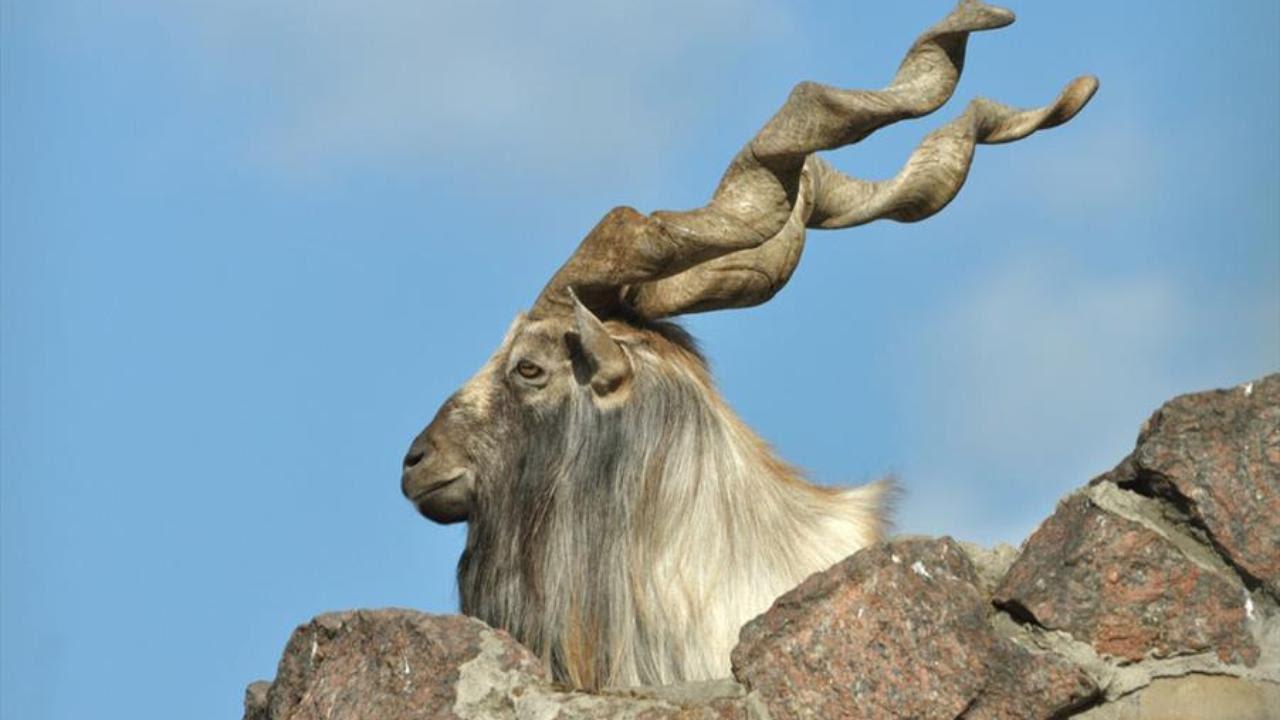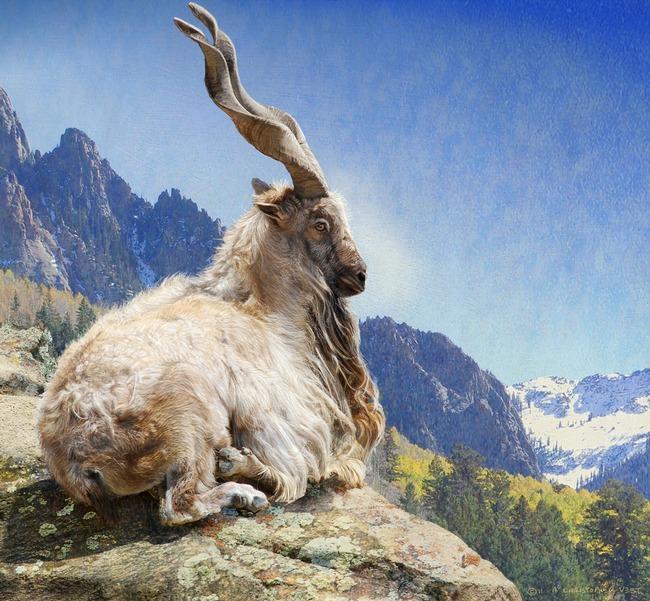The first image is the image on the left, the second image is the image on the right. For the images displayed, is the sentence "The left and right image contains the same number of goats facing the same direction." factually correct? Answer yes or no. No. The first image is the image on the left, the second image is the image on the right. Given the left and right images, does the statement "Each image contains one horned animal in front of a wall of rock, and the animals in the left and right images face the same way and have very similar body positions." hold true? Answer yes or no. No. 